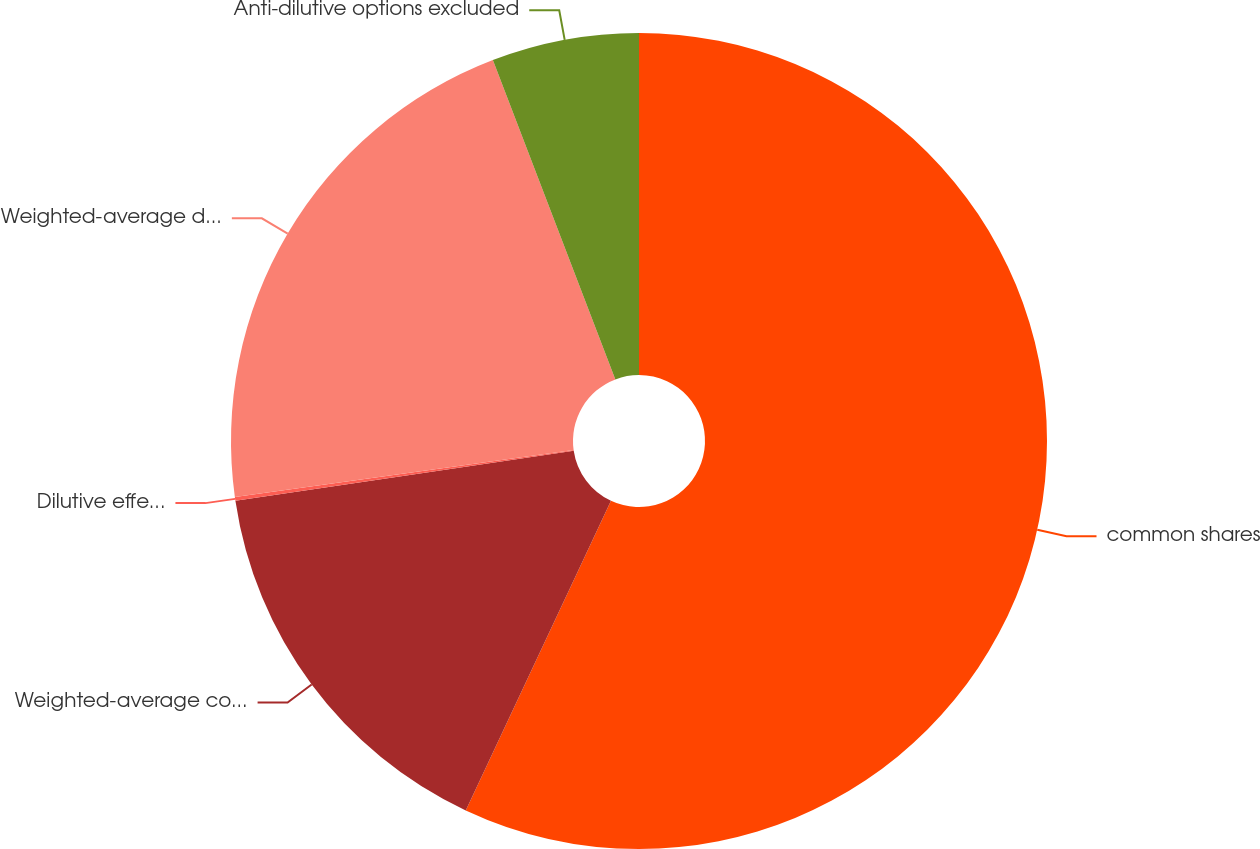Convert chart. <chart><loc_0><loc_0><loc_500><loc_500><pie_chart><fcel>common shares<fcel>Weighted-average common shares<fcel>Dilutive effect of share-based<fcel>Weighted-average diluted<fcel>Anti-dilutive options excluded<nl><fcel>56.98%<fcel>15.68%<fcel>0.15%<fcel>21.36%<fcel>5.83%<nl></chart> 